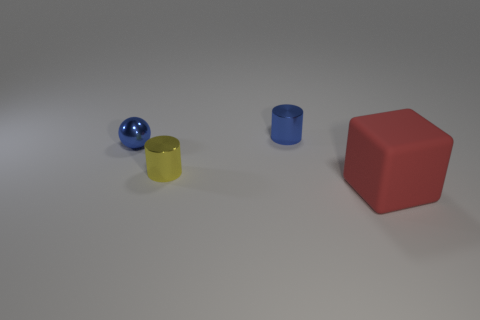Add 2 red objects. How many objects exist? 6 Subtract all cubes. How many objects are left? 3 Subtract all large green blocks. Subtract all tiny cylinders. How many objects are left? 2 Add 2 metallic things. How many metallic things are left? 5 Add 3 metal balls. How many metal balls exist? 4 Subtract 0 purple blocks. How many objects are left? 4 